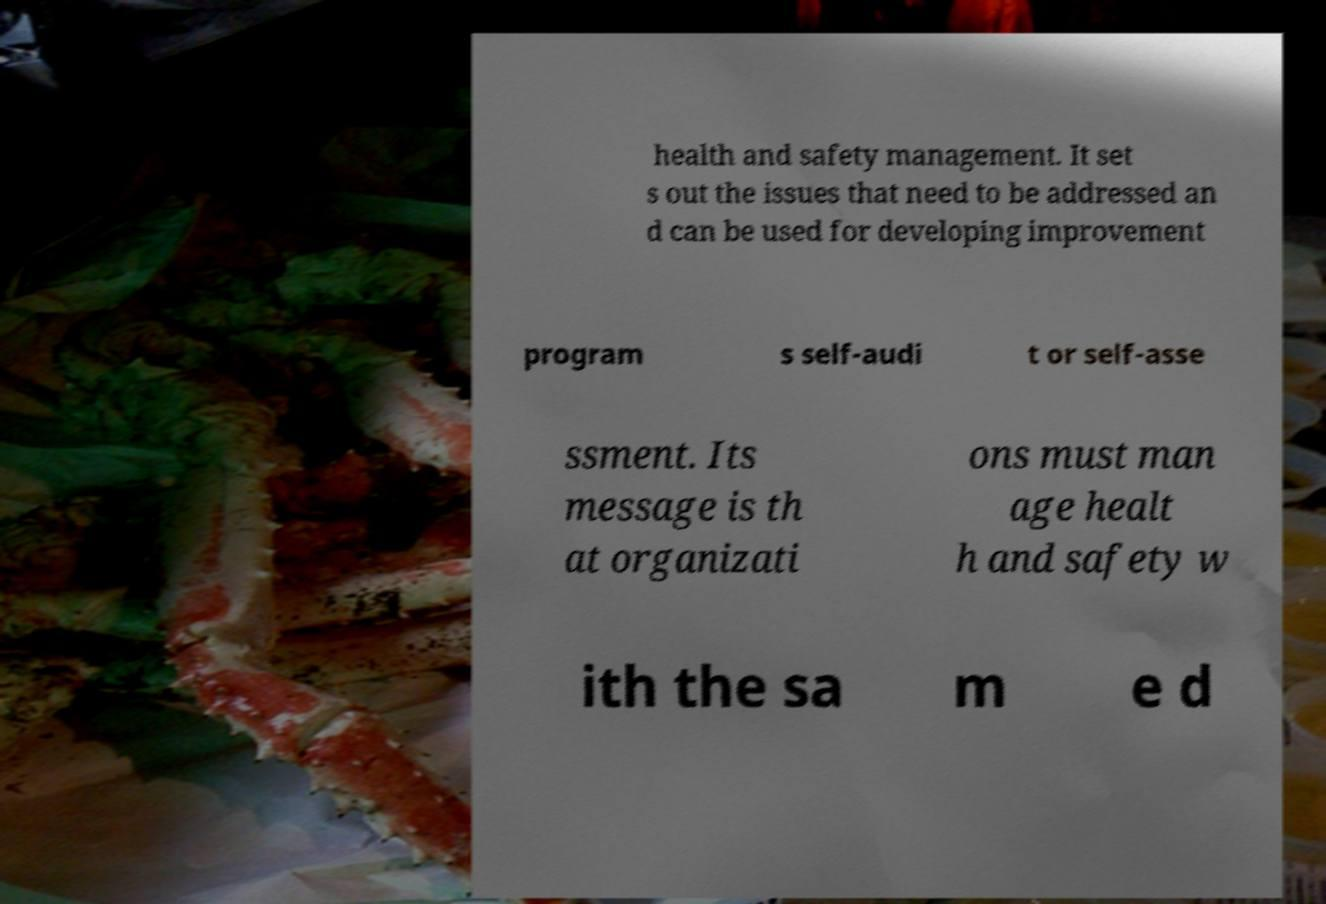For documentation purposes, I need the text within this image transcribed. Could you provide that? health and safety management. It set s out the issues that need to be addressed an d can be used for developing improvement program s self-audi t or self-asse ssment. Its message is th at organizati ons must man age healt h and safety w ith the sa m e d 